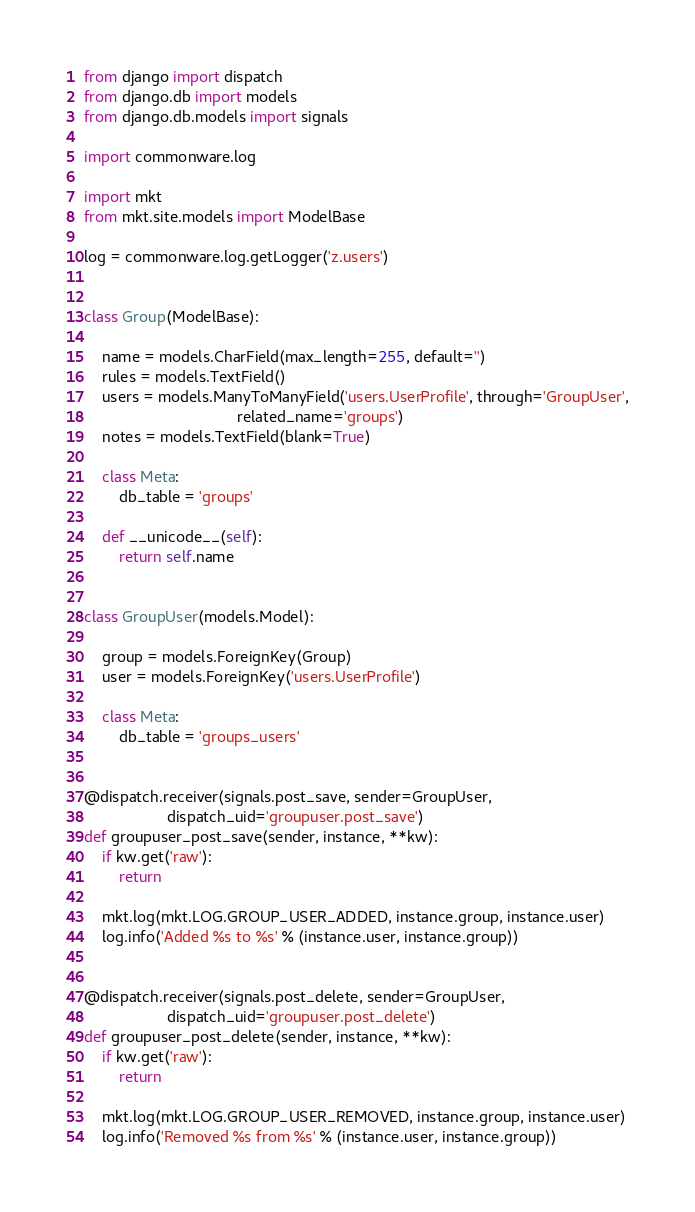Convert code to text. <code><loc_0><loc_0><loc_500><loc_500><_Python_>from django import dispatch
from django.db import models
from django.db.models import signals

import commonware.log

import mkt
from mkt.site.models import ModelBase

log = commonware.log.getLogger('z.users')


class Group(ModelBase):

    name = models.CharField(max_length=255, default='')
    rules = models.TextField()
    users = models.ManyToManyField('users.UserProfile', through='GroupUser',
                                   related_name='groups')
    notes = models.TextField(blank=True)

    class Meta:
        db_table = 'groups'

    def __unicode__(self):
        return self.name


class GroupUser(models.Model):

    group = models.ForeignKey(Group)
    user = models.ForeignKey('users.UserProfile')

    class Meta:
        db_table = 'groups_users'


@dispatch.receiver(signals.post_save, sender=GroupUser,
                   dispatch_uid='groupuser.post_save')
def groupuser_post_save(sender, instance, **kw):
    if kw.get('raw'):
        return

    mkt.log(mkt.LOG.GROUP_USER_ADDED, instance.group, instance.user)
    log.info('Added %s to %s' % (instance.user, instance.group))


@dispatch.receiver(signals.post_delete, sender=GroupUser,
                   dispatch_uid='groupuser.post_delete')
def groupuser_post_delete(sender, instance, **kw):
    if kw.get('raw'):
        return

    mkt.log(mkt.LOG.GROUP_USER_REMOVED, instance.group, instance.user)
    log.info('Removed %s from %s' % (instance.user, instance.group))
</code> 